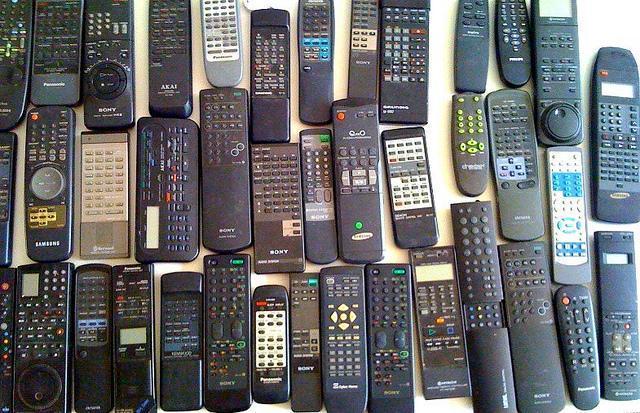How many remotes are there?
Give a very brief answer. 15. 